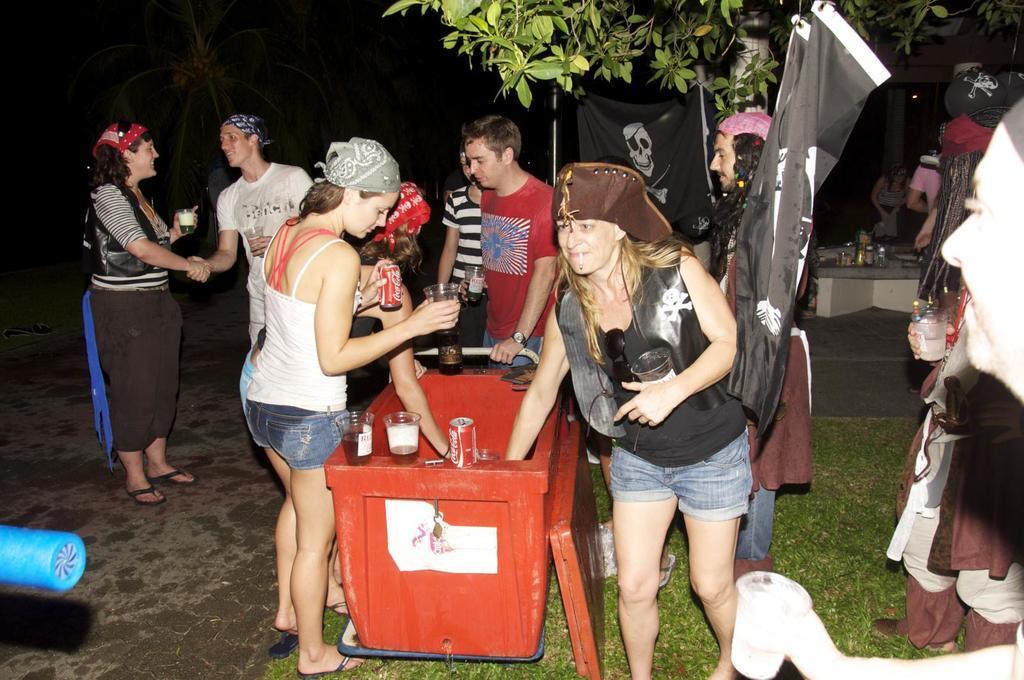Describe this image in one or two sentences. In this image I can see a group of people standing and holding something. I can see a red box,trees,black banners,grass and few objects. 